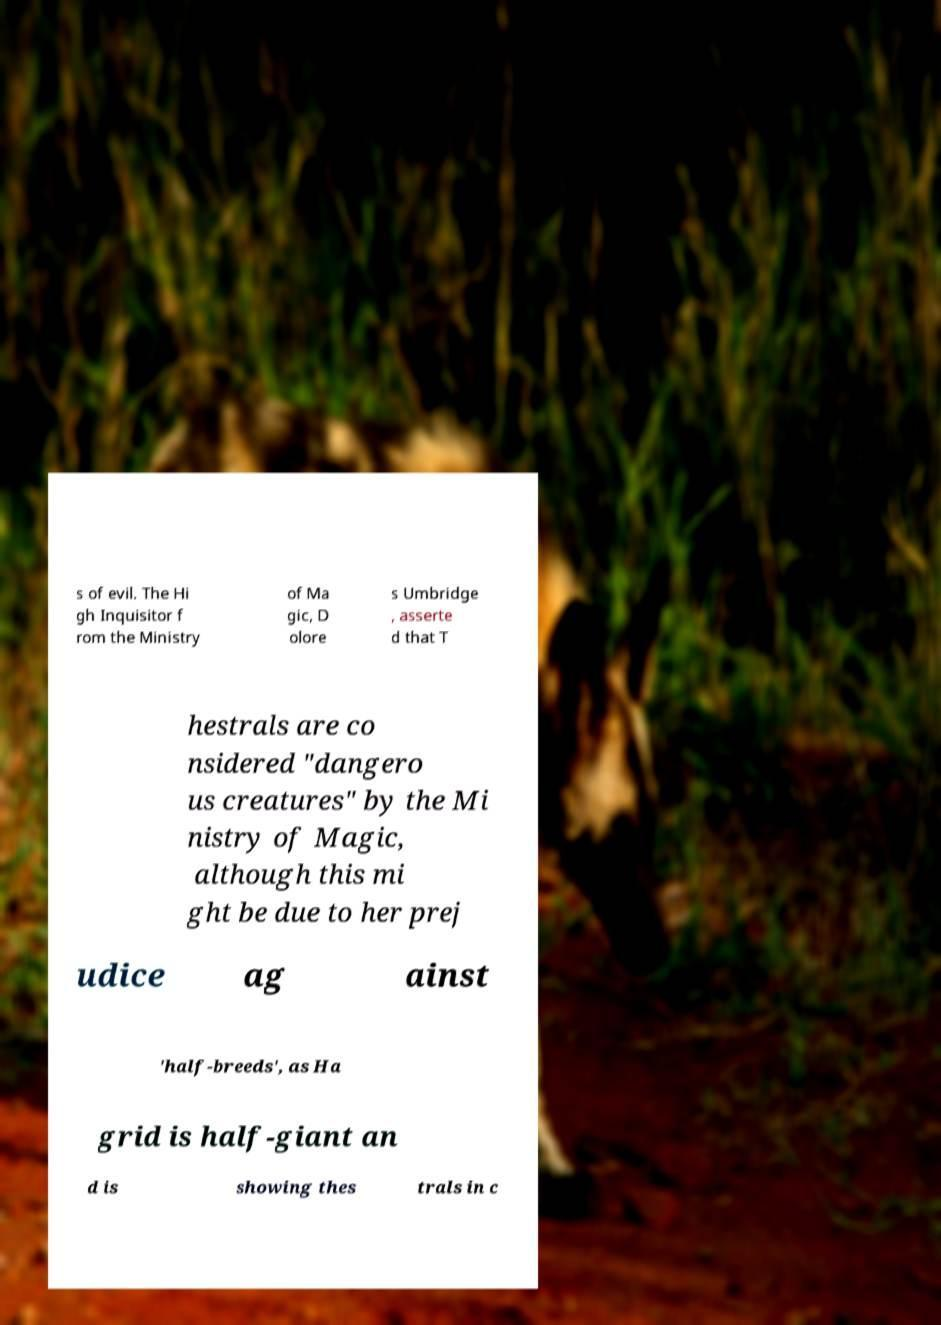Could you extract and type out the text from this image? s of evil. The Hi gh Inquisitor f rom the Ministry of Ma gic, D olore s Umbridge , asserte d that T hestrals are co nsidered "dangero us creatures" by the Mi nistry of Magic, although this mi ght be due to her prej udice ag ainst 'half-breeds', as Ha grid is half-giant an d is showing thes trals in c 